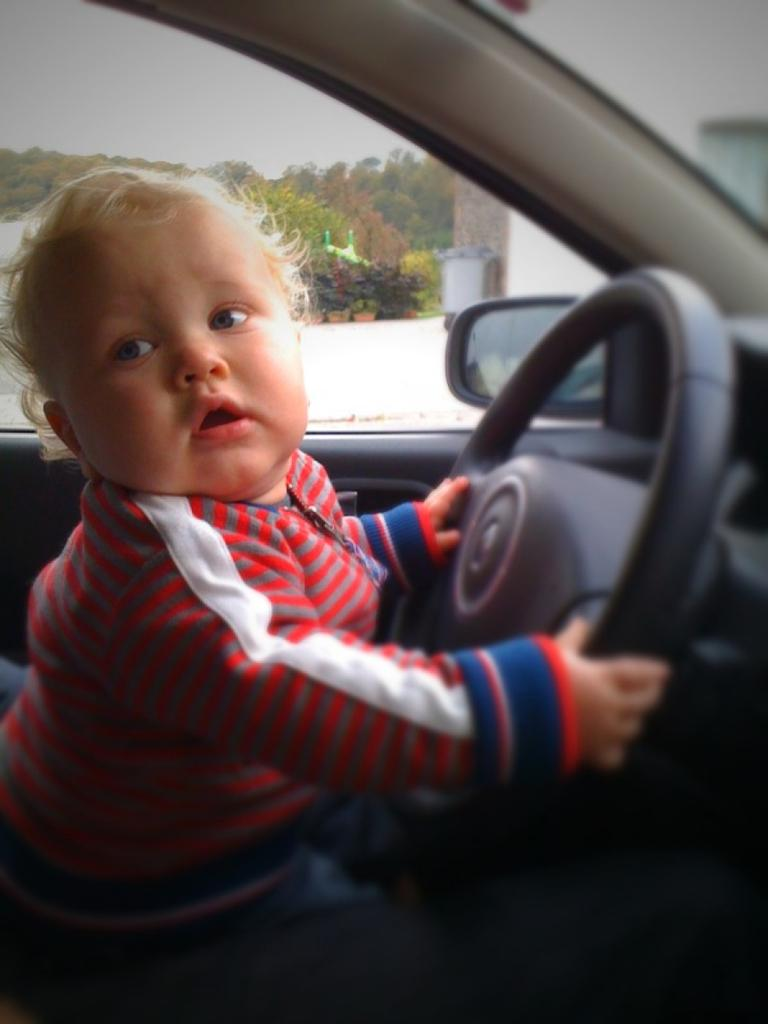What is the child doing in the car? The child is sitting in the car and holding the steering wheel with his hands. What can be seen outside the car? There is a building and trees visible outside the car. What is visible in the sky in the image? The sky is visible in the image. What type of zipper can be seen on the child's clothing in the image? There is no zipper visible on the child's clothing in the image. What type of trains can be seen passing by the car in the image? There are no trains visible in the image; only a building and trees can be seen outside the car. 